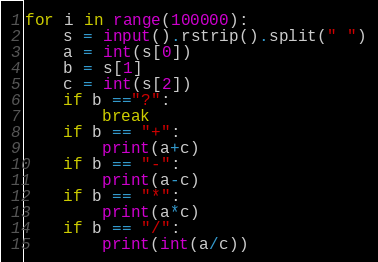<code> <loc_0><loc_0><loc_500><loc_500><_Python_>for i in range(100000):
    s = input().rstrip().split(" ")
    a = int(s[0])
    b = s[1]
    c = int(s[2])
    if b =="?":
        break
    if b == "+":
        print(a+c)
    if b == "-":
        print(a-c)
    if b == "*":
        print(a*c)
    if b == "/":
        print(int(a/c))
</code> 